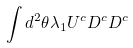<formula> <loc_0><loc_0><loc_500><loc_500>\int d ^ { 2 } \theta \lambda _ { 1 } U ^ { c } D ^ { c } D ^ { c }</formula> 